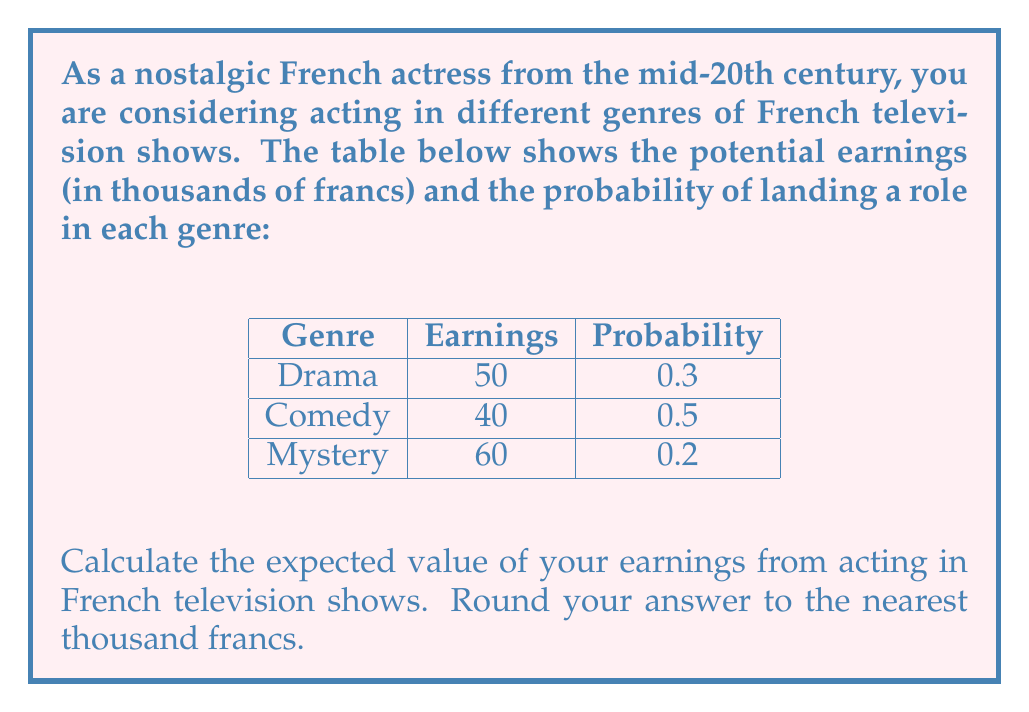Can you solve this math problem? To calculate the expected value, we need to multiply each potential outcome by its probability and then sum these products. Let's break it down step-by-step:

1) For Drama:
   Earnings = 50,000 francs
   Probability = 0.3
   Expected Value (Drama) = $50,000 \times 0.3 = 15,000$ francs

2) For Comedy:
   Earnings = 40,000 francs
   Probability = 0.5
   Expected Value (Comedy) = $40,000 \times 0.5 = 20,000$ francs

3) For Mystery:
   Earnings = 60,000 francs
   Probability = 0.2
   Expected Value (Mystery) = $60,000 \times 0.2 = 12,000$ francs

4) Total Expected Value:
   $$E = 15,000 + 20,000 + 12,000 = 47,000$$ francs

5) Rounding to the nearest thousand:
   47,000 francs rounds to 47,000 francs

Therefore, the expected value of your earnings from acting in French television shows is 47,000 francs.
Answer: 47,000 francs 